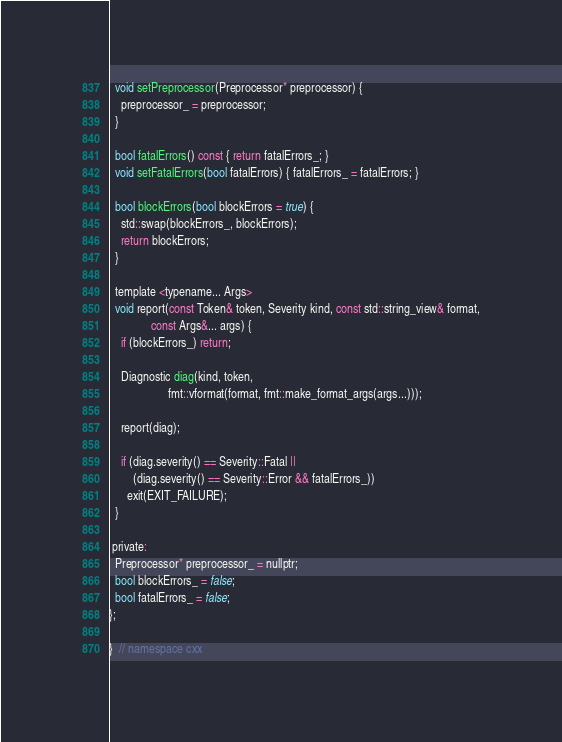<code> <loc_0><loc_0><loc_500><loc_500><_C_>
  void setPreprocessor(Preprocessor* preprocessor) {
    preprocessor_ = preprocessor;
  }

  bool fatalErrors() const { return fatalErrors_; }
  void setFatalErrors(bool fatalErrors) { fatalErrors_ = fatalErrors; }

  bool blockErrors(bool blockErrors = true) {
    std::swap(blockErrors_, blockErrors);
    return blockErrors;
  }

  template <typename... Args>
  void report(const Token& token, Severity kind, const std::string_view& format,
              const Args&... args) {
    if (blockErrors_) return;

    Diagnostic diag(kind, token,
                    fmt::vformat(format, fmt::make_format_args(args...)));

    report(diag);

    if (diag.severity() == Severity::Fatal ||
        (diag.severity() == Severity::Error && fatalErrors_))
      exit(EXIT_FAILURE);
  }

 private:
  Preprocessor* preprocessor_ = nullptr;
  bool blockErrors_ = false;
  bool fatalErrors_ = false;
};

}  // namespace cxx</code> 